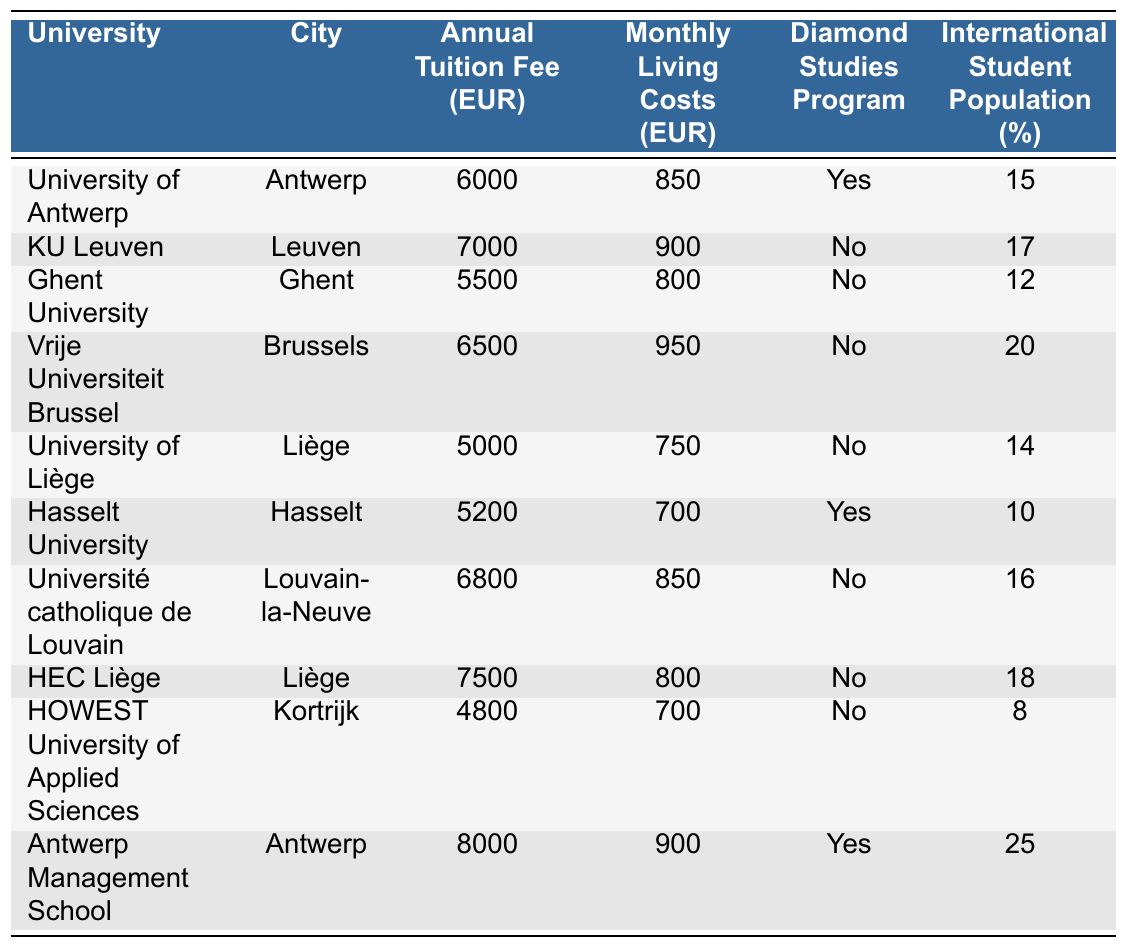What is the annual tuition fee for the University of Liège? The table shows that the University of Liège has an annual tuition fee of 5000 EUR listed under the "Annual Tuition Fee (EUR)" column.
Answer: 5000 EUR Which university in Antwerp has the highest tuition fee? According to the table, the Antwerp Management School has the highest tuition fee of 8000 EUR among the institutions listed in Antwerp.
Answer: Antwerp Management School What are the monthly living costs at Hasselt University? The monthly living costs for Hasselt University are 700 EUR, as indicated in the "Monthly Living Costs (EUR)" column.
Answer: 700 EUR What is the total annual tuition fee for KU Leuven and Vrije Universiteit Brussel? The annual tuition fee for KU Leuven is 7000 EUR and for Vrije Universiteit Brussel is 6500 EUR. Adding these together gives 7000 + 6500 = 13500 EUR.
Answer: 13500 EUR Does the University of Antwerp offer a Diamond Studies Program? From the table, it's indicated that the University of Antwerp does offer a Diamond Studies Program, as shown in the "Diamond Studies Program" column with a "Yes."
Answer: Yes What is the average monthly living cost across all universities in the table? To find the average monthly living costs, first sum all the monthly living costs: 850 + 900 + 800 + 950 + 750 + 700 + 850 + 800 + 700 + 900 = 8300 EUR. Then divide by the number of universities (10) to get 8300 / 10 = 830 EUR.
Answer: 830 EUR Which university has the largest percentage of international students? The table shows that Antwerp Management School has the largest percentage of international students at 25%, as listed in the "International Student Population (%)" column.
Answer: Antwerp Management School If I want to study Diamond Studies, which universities could I consider? The universities offering a Diamond Studies Program are the University of Antwerp and Hasselt University, as indicated in the "Diamond Studies Program" column with "Yes" for these institutions.
Answer: University of Antwerp, Hasselt University What is the difference in annual tuition fees between the most and least expensive universities? The most expensive university is Antwerp Management School at 8000 EUR and the least expensive is HOWEST University of Applied Sciences at 4800 EUR. The difference is 8000 - 4800 = 3200 EUR.
Answer: 3200 EUR What city has the university with the lowest living costs? From the table, the university with the lowest monthly living costs is HOWEST University of Applied Sciences, located in Kortrijk, which has living costs of 700 EUR.
Answer: Kortrijk 